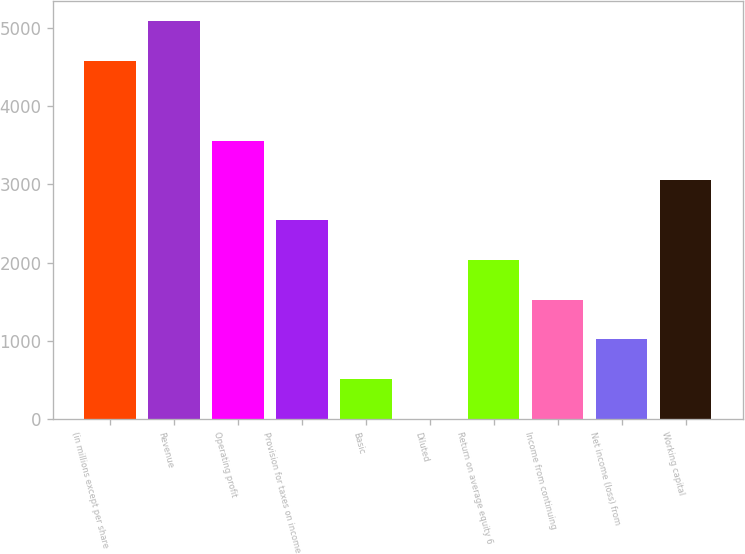<chart> <loc_0><loc_0><loc_500><loc_500><bar_chart><fcel>(in millions except per share<fcel>Revenue<fcel>Operating profit<fcel>Provision for taxes on income<fcel>Basic<fcel>Diluted<fcel>Return on average equity 6<fcel>Income from continuing<fcel>Net income (loss) from<fcel>Working capital<nl><fcel>4573.12<fcel>5080.99<fcel>3557.38<fcel>2541.64<fcel>510.16<fcel>2.29<fcel>2033.77<fcel>1525.9<fcel>1018.03<fcel>3049.51<nl></chart> 